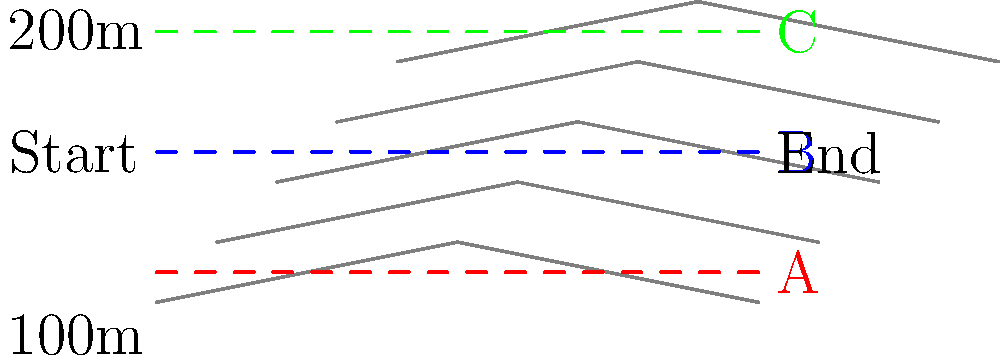Based on the topographical map provided, which of the three proposed road paths (A, B, or C) would be the most suitable for constructing a new highway between the start and end points? Consider factors such as elevation changes, construction costs, and overall efficiency. To determine the most suitable road path, we need to analyze each option based on the topographical information provided:

1. Path A (Red):
   - Follows the lowest elevation contour line.
   - Minimal elevation changes, resulting in a relatively flat road.
   - Requires the least amount of cut-and-fill operations.
   - Likely the least expensive option for construction.

2. Path B (Blue):
   - Runs through the middle of the map.
   - Moderate elevation changes, with some ups and downs.
   - Requires more earthwork than Path A, but less than Path C.
   - Represents a balance between construction costs and directness.

3. Path C (Green):
   - Follows the highest elevation contour line.
   - Maximum elevation changes, resulting in a road with significant grade variations.
   - Requires the most cut-and-fill operations.
   - Likely the most expensive option for construction.

Factors to consider:
1. Construction costs: Path A would be the least expensive due to minimal earthwork.
2. Fuel efficiency: Path A would be most fuel-efficient due to its flat profile.
3. Directness: All paths appear to have similar lengths.
4. Environmental impact: Path A likely has the least impact due to minimal terrain alterations.
5. Drainage: Path A may have potential drainage issues due to its low elevation, but this can be mitigated with proper engineering.

Considering these factors, Path A (Red) emerges as the most suitable option. It offers the best balance of low construction costs, fuel efficiency, and minimal environmental impact. While drainage might be a concern, it can be addressed through appropriate engineering solutions, which would still likely be more cost-effective than the extensive earthwork required for the other options.
Answer: Path A (Red) 